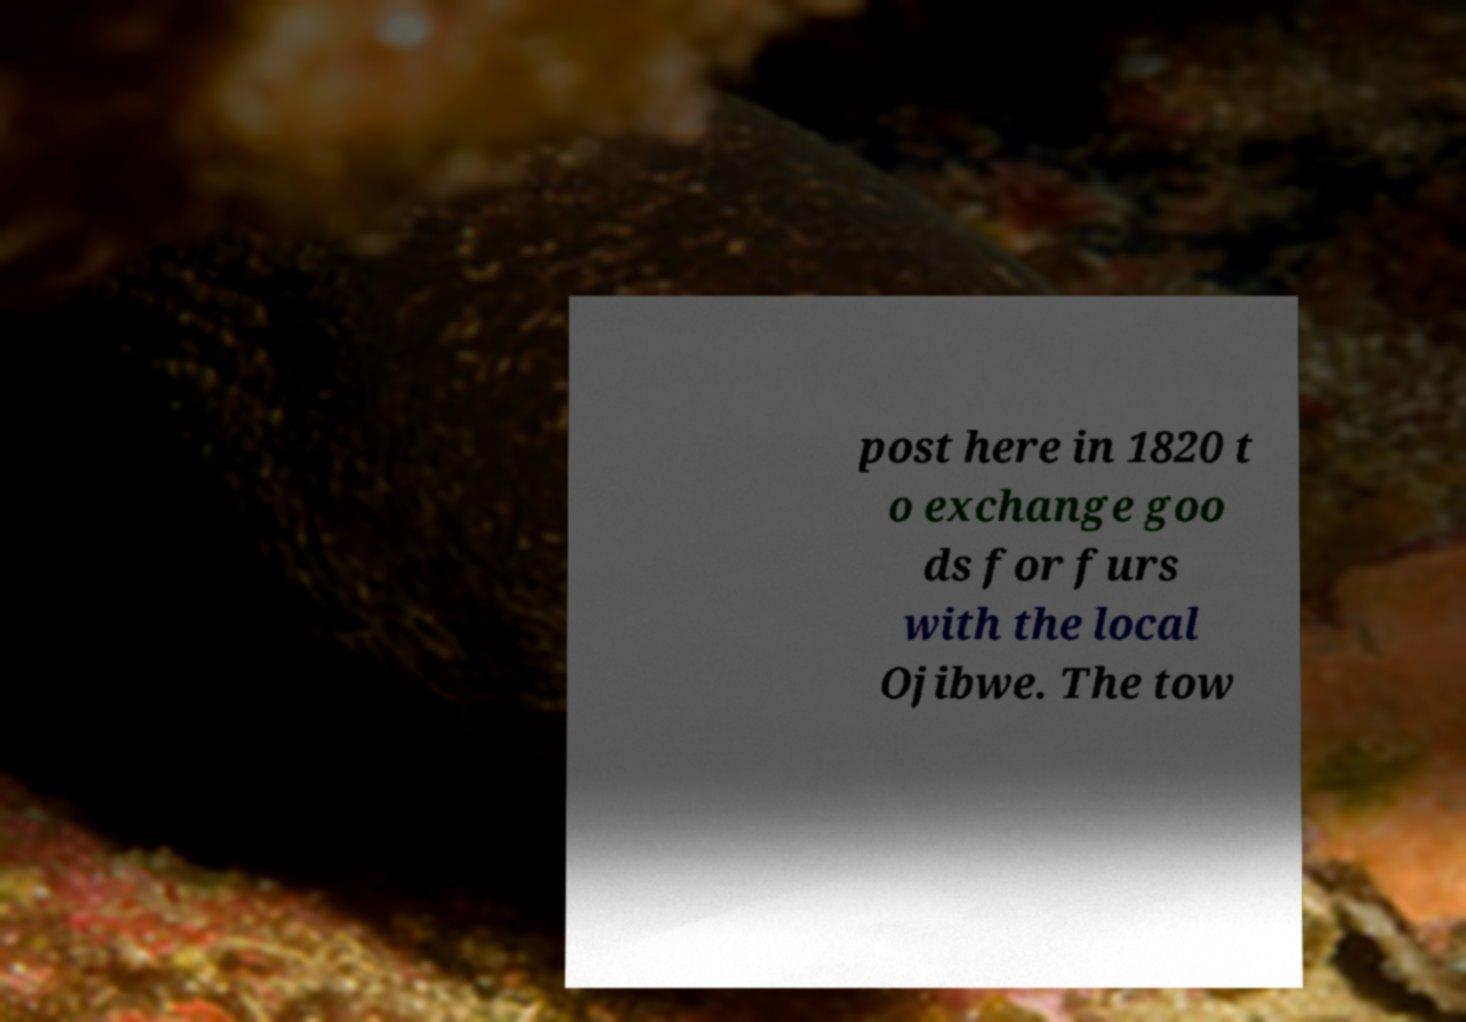Please identify and transcribe the text found in this image. post here in 1820 t o exchange goo ds for furs with the local Ojibwe. The tow 